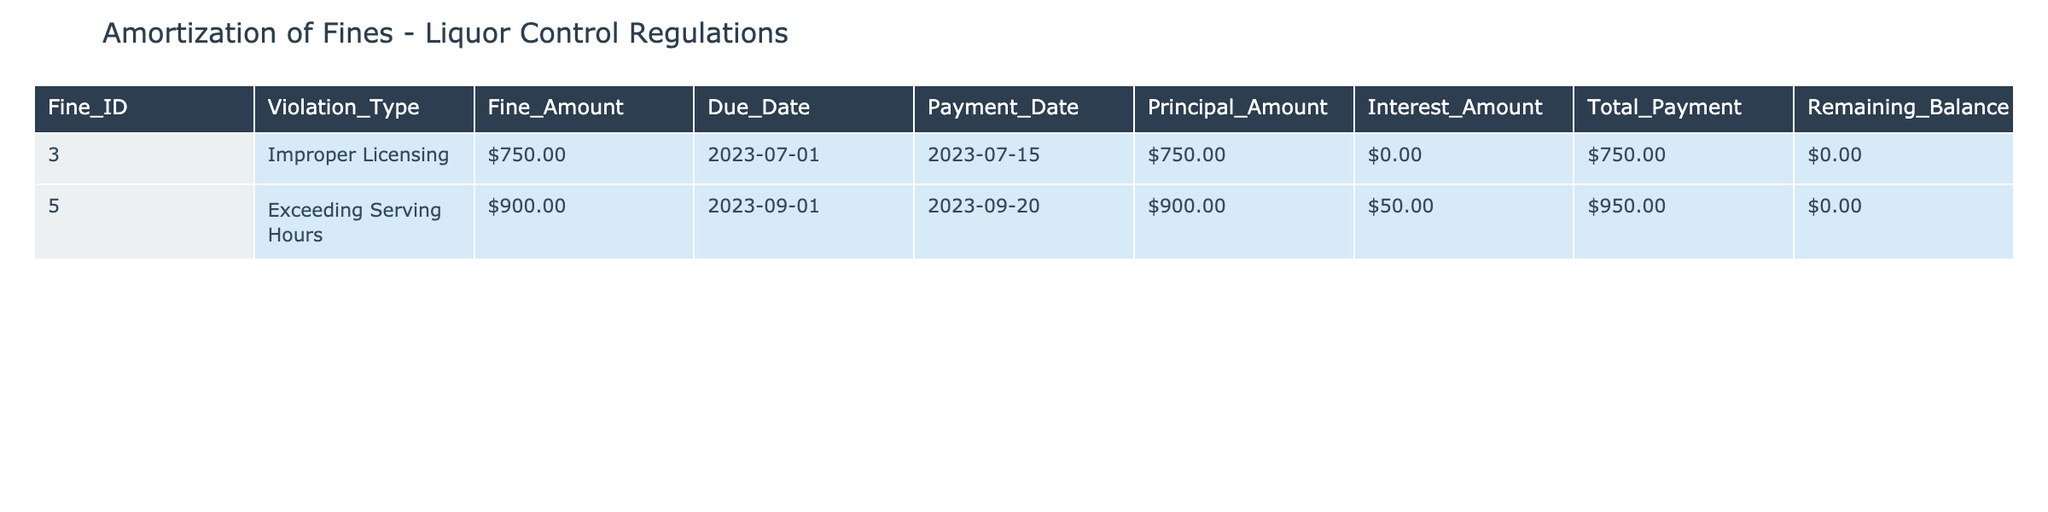What is the total fine amount collected from the violation of liquor control regulations? To find the total fine amount, add the Fine_Amount values from both fine records: $750.00 + $900.00 = $1,650.00.
Answer: $1,650.00 What is the due date for the fine related to exceeding serving hours? Refer to the Due_Date column for the fine ID 005, which shows the due date is 2023-09-01.
Answer: 2023-09-01 Is there any interest amount applied to the fine for improper licensing? Checking the Interest_Amount for fine ID 003, it is $0.00, indicating no interest was applied.
Answer: No What is the total payment amount for the exceeding serving hours violation? In the table, the Total_Payment for fine ID 005 is listed as $950.00.
Answer: $950.00 What is the remaining balance for the improper licensing fine after payment? The Remaining_Balance for fine ID 003 is $0.00, indicating it has been fully paid.
Answer: $0.00 What is the average principal amount of the fines listed in the table? To find the average, add the Principal_Amounts ($750.00 + $900.00 = $1,650.00) and divide by the number of fines (2): $1,650.00 / 2 = $825.00.
Answer: $825.00 Was the fine for exceeding serving hours paid by its due date? The Payment_Date for fine ID 005 is 2023-09-20, which is after the Due_Date of 2023-09-01, indicating it was late.
Answer: No What is the difference between the total fine amount for both violations and the total interest amount charged? The total fine amount is $1,650.00 (from both fines) and the total interest amount is $50.00 (only from the exceeding serving hours). The difference is $1,650.00 - $50.00 = $1,600.00.
Answer: $1,600.00 